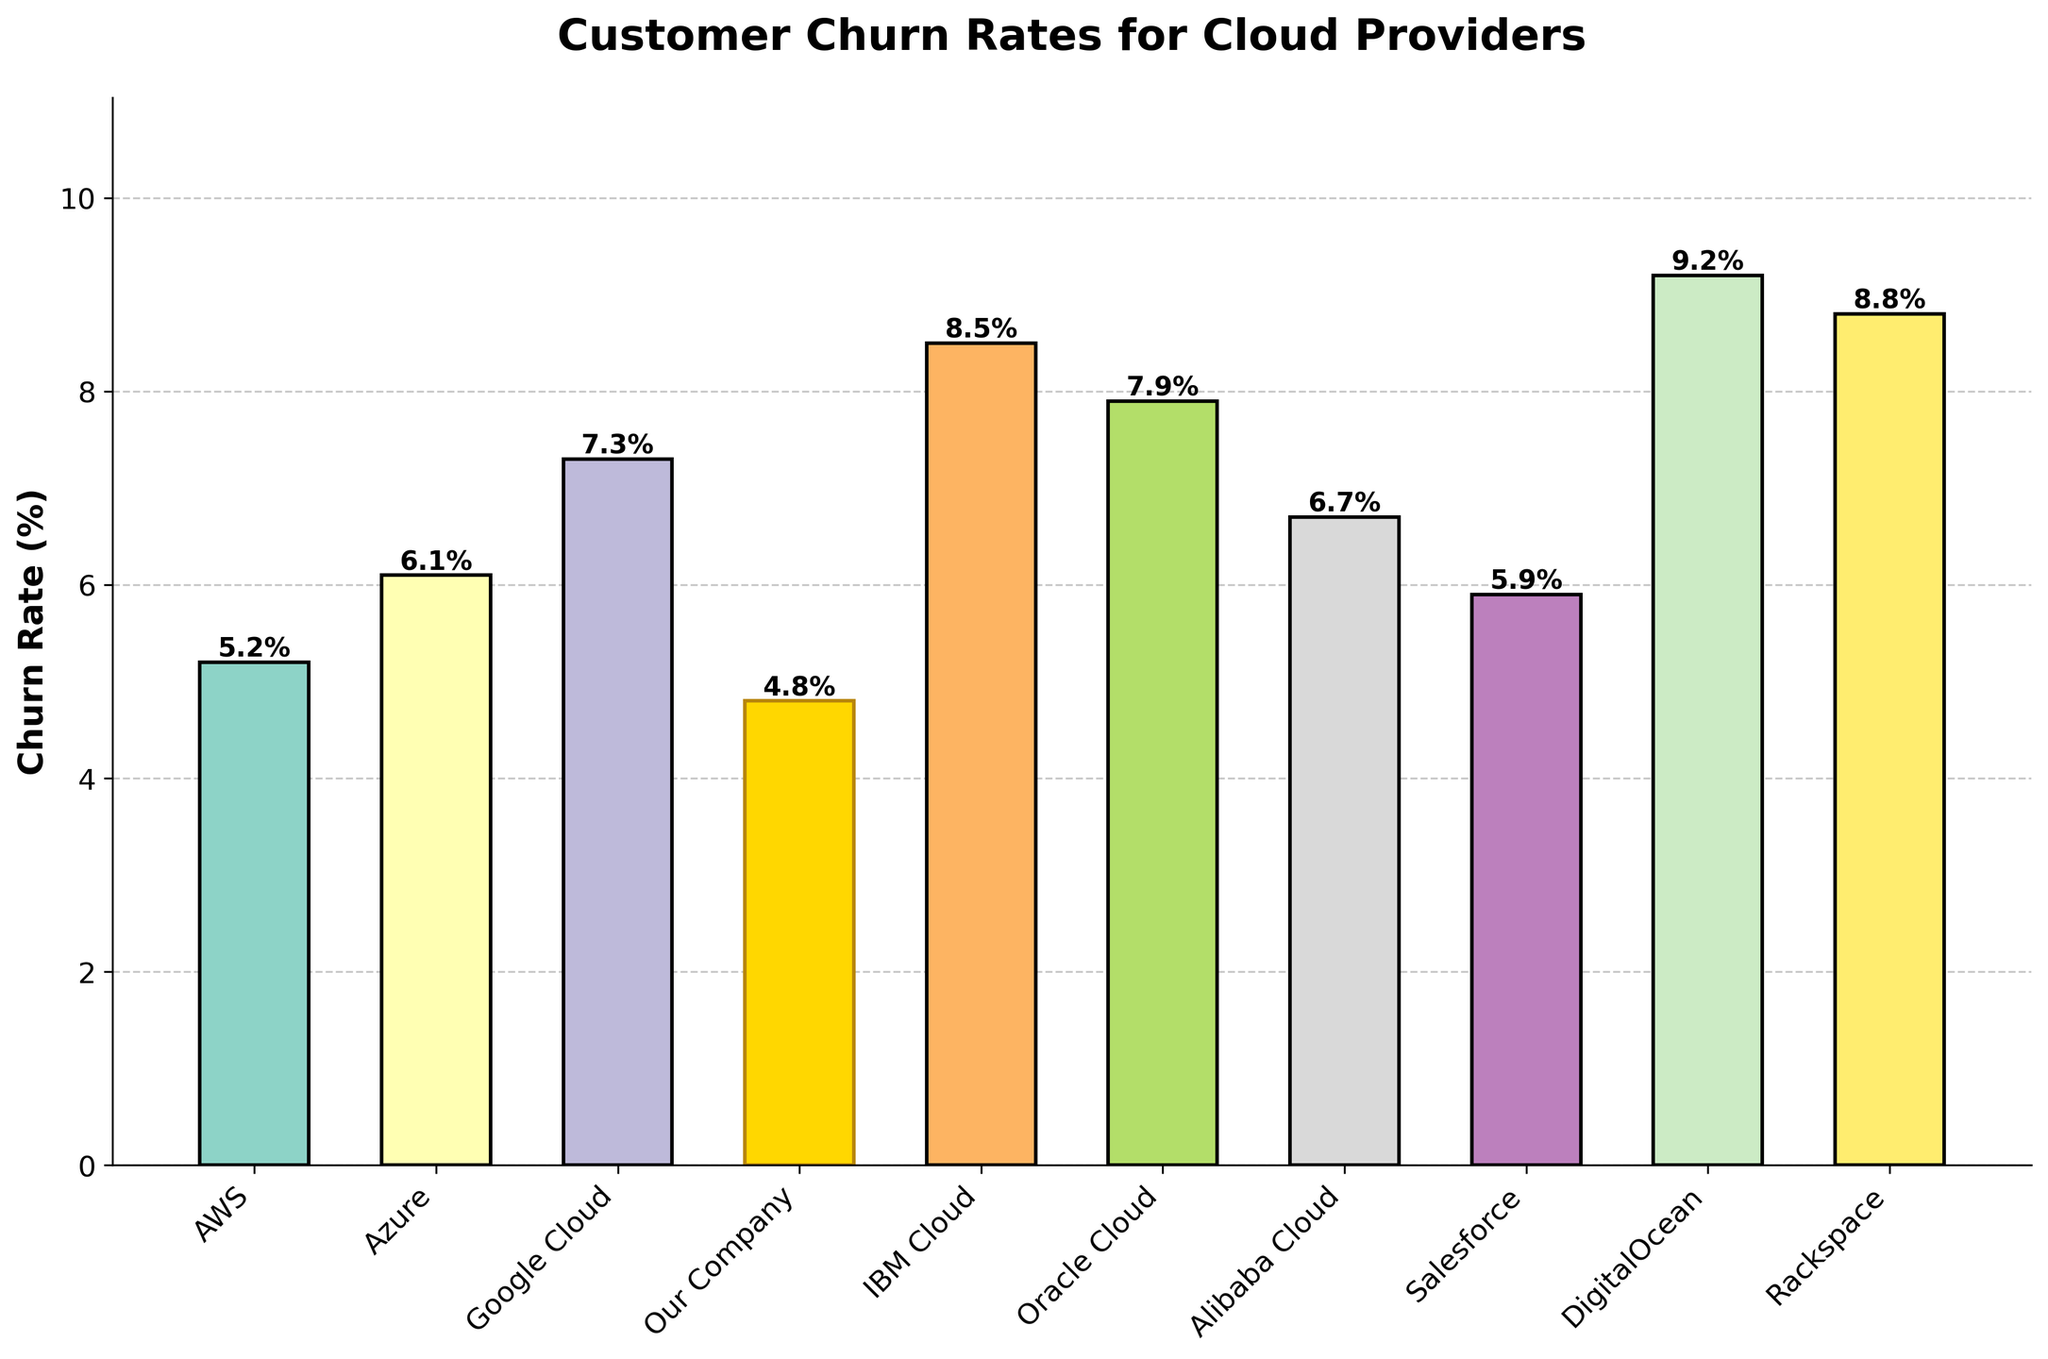What is the highest churn rate among the cloud providers? By observing the height of the bars, the highest bar represents DigitalOcean with a churn rate of 9.2%.
Answer: 9.2% What is the difference in churn rate between the provider with the highest churn rate and our company? DigitalOcean has the highest churn rate of 9.2%, and our company has a churn rate of 4.8%. The difference is 9.2% - 4.8% = 4.4%.
Answer: 4.4% Which cloud provider has a churn rate closest to our company's churn rate? By comparing the heights of the bars, Salesforce has a churn rate of 5.9%, which is closest to our company's churn rate of 4.8%.
Answer: Salesforce How many cloud providers have a churn rate higher than 7%? By counting the number of bars that extend above the 7% mark, we see that there are five providers: Google Cloud, IBM Cloud, Oracle Cloud, DigitalOcean, and Rackspace.
Answer: 5 Which cloud provider has the lowest churn rate? The shortest bar represents our company, with a churn rate of 4.8%.
Answer: Our Company What is the average churn rate of the cloud providers? Sum the churn rates: 5.2 + 6.1 + 7.3 + 4.8 + 8.5 + 7.9 + 6.7 + 5.9 + 9.2 + 8.8 = 70.4. There are 10 providers, so the average is 70.4 / 10 = 7.04%.
Answer: 7.04% Is the churn rate of Oracle Cloud higher or lower than that of IBM Cloud? Oracle Cloud has a churn rate of 7.9%, while IBM Cloud has a churn rate of 8.5%, so Oracle Cloud's churn rate is lower.
Answer: Lower What is the sum of the churn rates for companies with less than 6% churn? The companies with less than 6% churn are AWS (5.2%), our company (4.8%), and Salesforce (5.9%). Sum: 5.2 + 4.8 + 5.9 = 15.9%.
Answer: 15.9% What is the range of the churn rates among the cloud providers? The range is calculated by subtracting the lowest churn rate (4.8% - from our company) from the highest churn rate (9.2% - from DigitalOcean). The range is 9.2% - 4.8% = 4.4%.
Answer: 4.4% Which cloud provider's bar is colored gold, and what is its churn rate? The bar colored gold represents our company, and the churn rate is 4.8%.
Answer: Our Company, 4.8% 